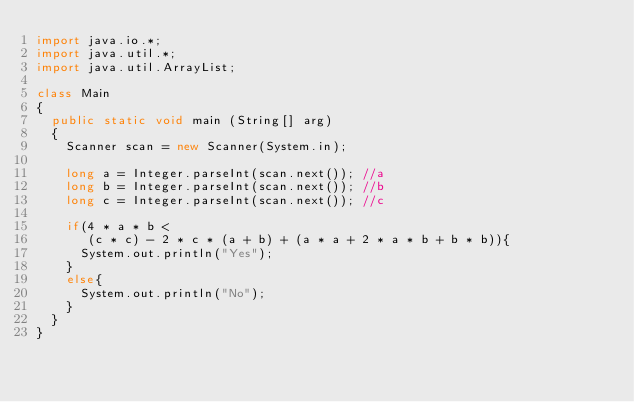<code> <loc_0><loc_0><loc_500><loc_500><_Java_>import java.io.*;
import java.util.*;
import java.util.ArrayList;
 
class Main
{
  public static void main (String[] arg)
  {
    Scanner scan = new Scanner(System.in);
    
    long a = Integer.parseInt(scan.next()); //a
    long b = Integer.parseInt(scan.next()); //b
    long c = Integer.parseInt(scan.next()); //c
    
    if(4 * a * b < 
       (c * c) - 2 * c * (a + b) + (a * a + 2 * a * b + b * b)){
      System.out.println("Yes");
    }
    else{
      System.out.println("No");
    }
  }
}
</code> 